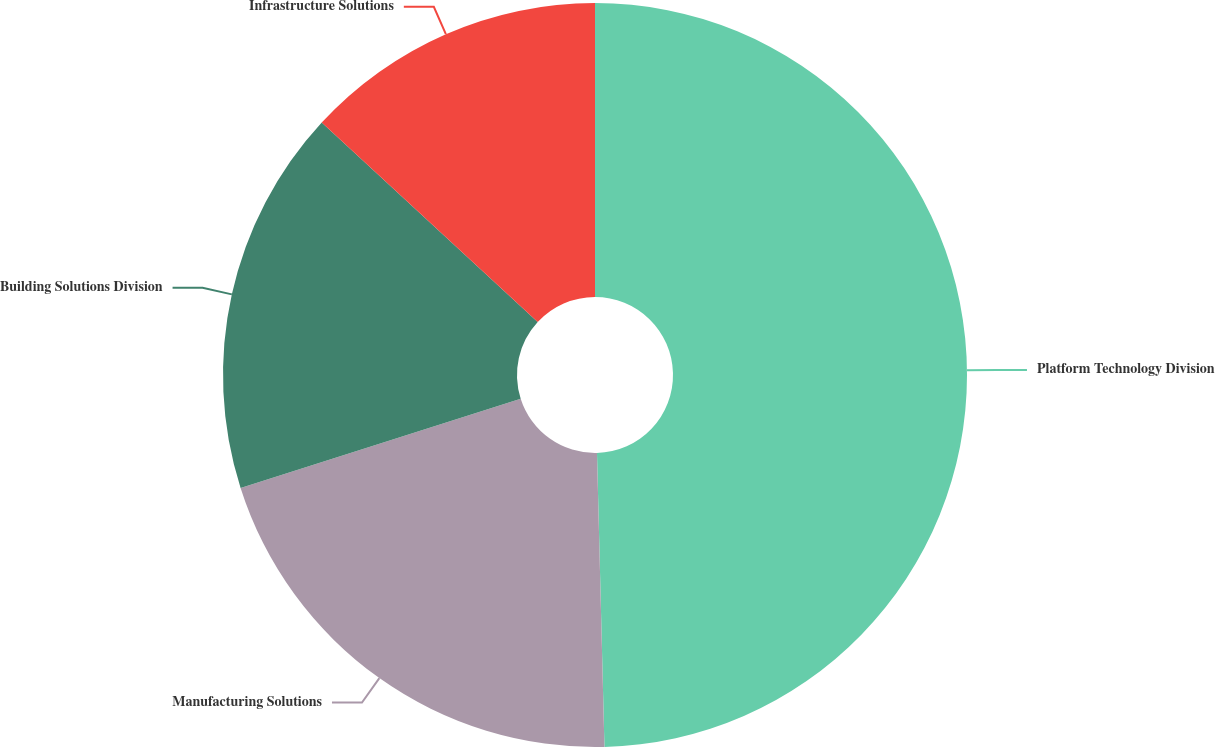Convert chart to OTSL. <chart><loc_0><loc_0><loc_500><loc_500><pie_chart><fcel>Platform Technology Division<fcel>Manufacturing Solutions<fcel>Building Solutions Division<fcel>Infrastructure Solutions<nl><fcel>49.59%<fcel>20.49%<fcel>16.78%<fcel>13.13%<nl></chart> 